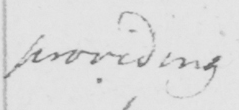What does this handwritten line say? providing 